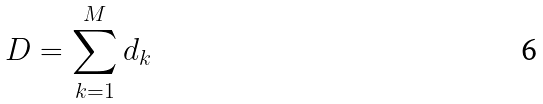Convert formula to latex. <formula><loc_0><loc_0><loc_500><loc_500>D = \sum _ { k = 1 } ^ { M } d _ { k }</formula> 